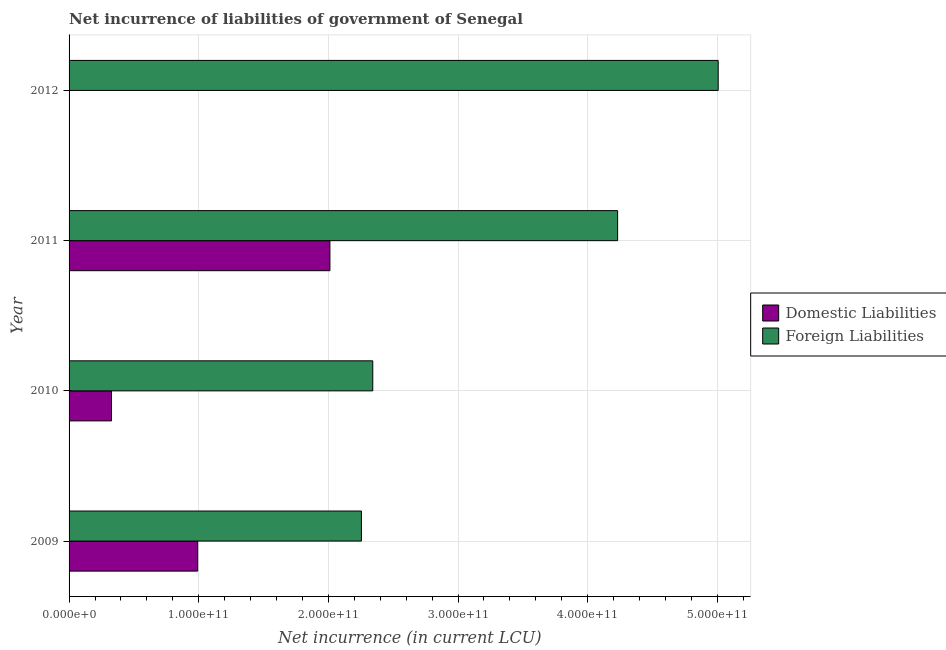How many different coloured bars are there?
Provide a succinct answer. 2. Are the number of bars per tick equal to the number of legend labels?
Keep it short and to the point. No. In how many cases, is the number of bars for a given year not equal to the number of legend labels?
Make the answer very short. 1. What is the net incurrence of foreign liabilities in 2009?
Make the answer very short. 2.26e+11. Across all years, what is the maximum net incurrence of foreign liabilities?
Keep it short and to the point. 5.01e+11. Across all years, what is the minimum net incurrence of foreign liabilities?
Offer a very short reply. 2.26e+11. What is the total net incurrence of domestic liabilities in the graph?
Provide a succinct answer. 3.33e+11. What is the difference between the net incurrence of foreign liabilities in 2011 and that in 2012?
Offer a terse response. -7.76e+1. What is the difference between the net incurrence of domestic liabilities in 2011 and the net incurrence of foreign liabilities in 2010?
Your response must be concise. -3.31e+1. What is the average net incurrence of domestic liabilities per year?
Offer a very short reply. 8.33e+1. In the year 2011, what is the difference between the net incurrence of domestic liabilities and net incurrence of foreign liabilities?
Ensure brevity in your answer.  -2.22e+11. What is the ratio of the net incurrence of domestic liabilities in 2009 to that in 2011?
Offer a terse response. 0.49. Is the difference between the net incurrence of domestic liabilities in 2009 and 2011 greater than the difference between the net incurrence of foreign liabilities in 2009 and 2011?
Offer a terse response. Yes. What is the difference between the highest and the second highest net incurrence of foreign liabilities?
Offer a terse response. 7.76e+1. What is the difference between the highest and the lowest net incurrence of domestic liabilities?
Your answer should be compact. 2.01e+11. In how many years, is the net incurrence of foreign liabilities greater than the average net incurrence of foreign liabilities taken over all years?
Provide a succinct answer. 2. Is the sum of the net incurrence of domestic liabilities in 2010 and 2011 greater than the maximum net incurrence of foreign liabilities across all years?
Provide a short and direct response. No. What is the difference between two consecutive major ticks on the X-axis?
Make the answer very short. 1.00e+11. Does the graph contain grids?
Give a very brief answer. Yes. Where does the legend appear in the graph?
Offer a very short reply. Center right. How many legend labels are there?
Your answer should be compact. 2. How are the legend labels stacked?
Your response must be concise. Vertical. What is the title of the graph?
Ensure brevity in your answer.  Net incurrence of liabilities of government of Senegal. What is the label or title of the X-axis?
Your answer should be very brief. Net incurrence (in current LCU). What is the label or title of the Y-axis?
Give a very brief answer. Year. What is the Net incurrence (in current LCU) in Domestic Liabilities in 2009?
Offer a very short reply. 9.92e+1. What is the Net incurrence (in current LCU) of Foreign Liabilities in 2009?
Your response must be concise. 2.26e+11. What is the Net incurrence (in current LCU) in Domestic Liabilities in 2010?
Provide a short and direct response. 3.27e+1. What is the Net incurrence (in current LCU) of Foreign Liabilities in 2010?
Offer a terse response. 2.34e+11. What is the Net incurrence (in current LCU) in Domestic Liabilities in 2011?
Your answer should be compact. 2.01e+11. What is the Net incurrence (in current LCU) in Foreign Liabilities in 2011?
Provide a short and direct response. 4.23e+11. What is the Net incurrence (in current LCU) of Foreign Liabilities in 2012?
Ensure brevity in your answer.  5.01e+11. Across all years, what is the maximum Net incurrence (in current LCU) of Domestic Liabilities?
Ensure brevity in your answer.  2.01e+11. Across all years, what is the maximum Net incurrence (in current LCU) in Foreign Liabilities?
Your response must be concise. 5.01e+11. Across all years, what is the minimum Net incurrence (in current LCU) of Domestic Liabilities?
Your response must be concise. 0. Across all years, what is the minimum Net incurrence (in current LCU) in Foreign Liabilities?
Your answer should be very brief. 2.26e+11. What is the total Net incurrence (in current LCU) in Domestic Liabilities in the graph?
Provide a short and direct response. 3.33e+11. What is the total Net incurrence (in current LCU) of Foreign Liabilities in the graph?
Make the answer very short. 1.38e+12. What is the difference between the Net incurrence (in current LCU) of Domestic Liabilities in 2009 and that in 2010?
Offer a terse response. 6.65e+1. What is the difference between the Net incurrence (in current LCU) of Foreign Liabilities in 2009 and that in 2010?
Provide a short and direct response. -8.75e+09. What is the difference between the Net incurrence (in current LCU) in Domestic Liabilities in 2009 and that in 2011?
Offer a very short reply. -1.02e+11. What is the difference between the Net incurrence (in current LCU) in Foreign Liabilities in 2009 and that in 2011?
Offer a very short reply. -1.98e+11. What is the difference between the Net incurrence (in current LCU) of Foreign Liabilities in 2009 and that in 2012?
Give a very brief answer. -2.75e+11. What is the difference between the Net incurrence (in current LCU) in Domestic Liabilities in 2010 and that in 2011?
Keep it short and to the point. -1.68e+11. What is the difference between the Net incurrence (in current LCU) of Foreign Liabilities in 2010 and that in 2011?
Provide a short and direct response. -1.89e+11. What is the difference between the Net incurrence (in current LCU) of Foreign Liabilities in 2010 and that in 2012?
Your answer should be very brief. -2.66e+11. What is the difference between the Net incurrence (in current LCU) of Foreign Liabilities in 2011 and that in 2012?
Ensure brevity in your answer.  -7.76e+1. What is the difference between the Net incurrence (in current LCU) of Domestic Liabilities in 2009 and the Net incurrence (in current LCU) of Foreign Liabilities in 2010?
Give a very brief answer. -1.35e+11. What is the difference between the Net incurrence (in current LCU) of Domestic Liabilities in 2009 and the Net incurrence (in current LCU) of Foreign Liabilities in 2011?
Provide a short and direct response. -3.24e+11. What is the difference between the Net incurrence (in current LCU) in Domestic Liabilities in 2009 and the Net incurrence (in current LCU) in Foreign Liabilities in 2012?
Provide a succinct answer. -4.02e+11. What is the difference between the Net incurrence (in current LCU) in Domestic Liabilities in 2010 and the Net incurrence (in current LCU) in Foreign Liabilities in 2011?
Ensure brevity in your answer.  -3.90e+11. What is the difference between the Net incurrence (in current LCU) of Domestic Liabilities in 2010 and the Net incurrence (in current LCU) of Foreign Liabilities in 2012?
Offer a terse response. -4.68e+11. What is the difference between the Net incurrence (in current LCU) in Domestic Liabilities in 2011 and the Net incurrence (in current LCU) in Foreign Liabilities in 2012?
Your response must be concise. -3.00e+11. What is the average Net incurrence (in current LCU) of Domestic Liabilities per year?
Ensure brevity in your answer.  8.33e+1. What is the average Net incurrence (in current LCU) of Foreign Liabilities per year?
Keep it short and to the point. 3.46e+11. In the year 2009, what is the difference between the Net incurrence (in current LCU) of Domestic Liabilities and Net incurrence (in current LCU) of Foreign Liabilities?
Your answer should be compact. -1.26e+11. In the year 2010, what is the difference between the Net incurrence (in current LCU) in Domestic Liabilities and Net incurrence (in current LCU) in Foreign Liabilities?
Ensure brevity in your answer.  -2.02e+11. In the year 2011, what is the difference between the Net incurrence (in current LCU) of Domestic Liabilities and Net incurrence (in current LCU) of Foreign Liabilities?
Your answer should be compact. -2.22e+11. What is the ratio of the Net incurrence (in current LCU) in Domestic Liabilities in 2009 to that in 2010?
Keep it short and to the point. 3.03. What is the ratio of the Net incurrence (in current LCU) in Foreign Liabilities in 2009 to that in 2010?
Keep it short and to the point. 0.96. What is the ratio of the Net incurrence (in current LCU) in Domestic Liabilities in 2009 to that in 2011?
Keep it short and to the point. 0.49. What is the ratio of the Net incurrence (in current LCU) in Foreign Liabilities in 2009 to that in 2011?
Ensure brevity in your answer.  0.53. What is the ratio of the Net incurrence (in current LCU) in Foreign Liabilities in 2009 to that in 2012?
Give a very brief answer. 0.45. What is the ratio of the Net incurrence (in current LCU) of Domestic Liabilities in 2010 to that in 2011?
Make the answer very short. 0.16. What is the ratio of the Net incurrence (in current LCU) of Foreign Liabilities in 2010 to that in 2011?
Offer a very short reply. 0.55. What is the ratio of the Net incurrence (in current LCU) of Foreign Liabilities in 2010 to that in 2012?
Give a very brief answer. 0.47. What is the ratio of the Net incurrence (in current LCU) of Foreign Liabilities in 2011 to that in 2012?
Offer a terse response. 0.84. What is the difference between the highest and the second highest Net incurrence (in current LCU) of Domestic Liabilities?
Ensure brevity in your answer.  1.02e+11. What is the difference between the highest and the second highest Net incurrence (in current LCU) in Foreign Liabilities?
Make the answer very short. 7.76e+1. What is the difference between the highest and the lowest Net incurrence (in current LCU) in Domestic Liabilities?
Offer a very short reply. 2.01e+11. What is the difference between the highest and the lowest Net incurrence (in current LCU) of Foreign Liabilities?
Provide a succinct answer. 2.75e+11. 